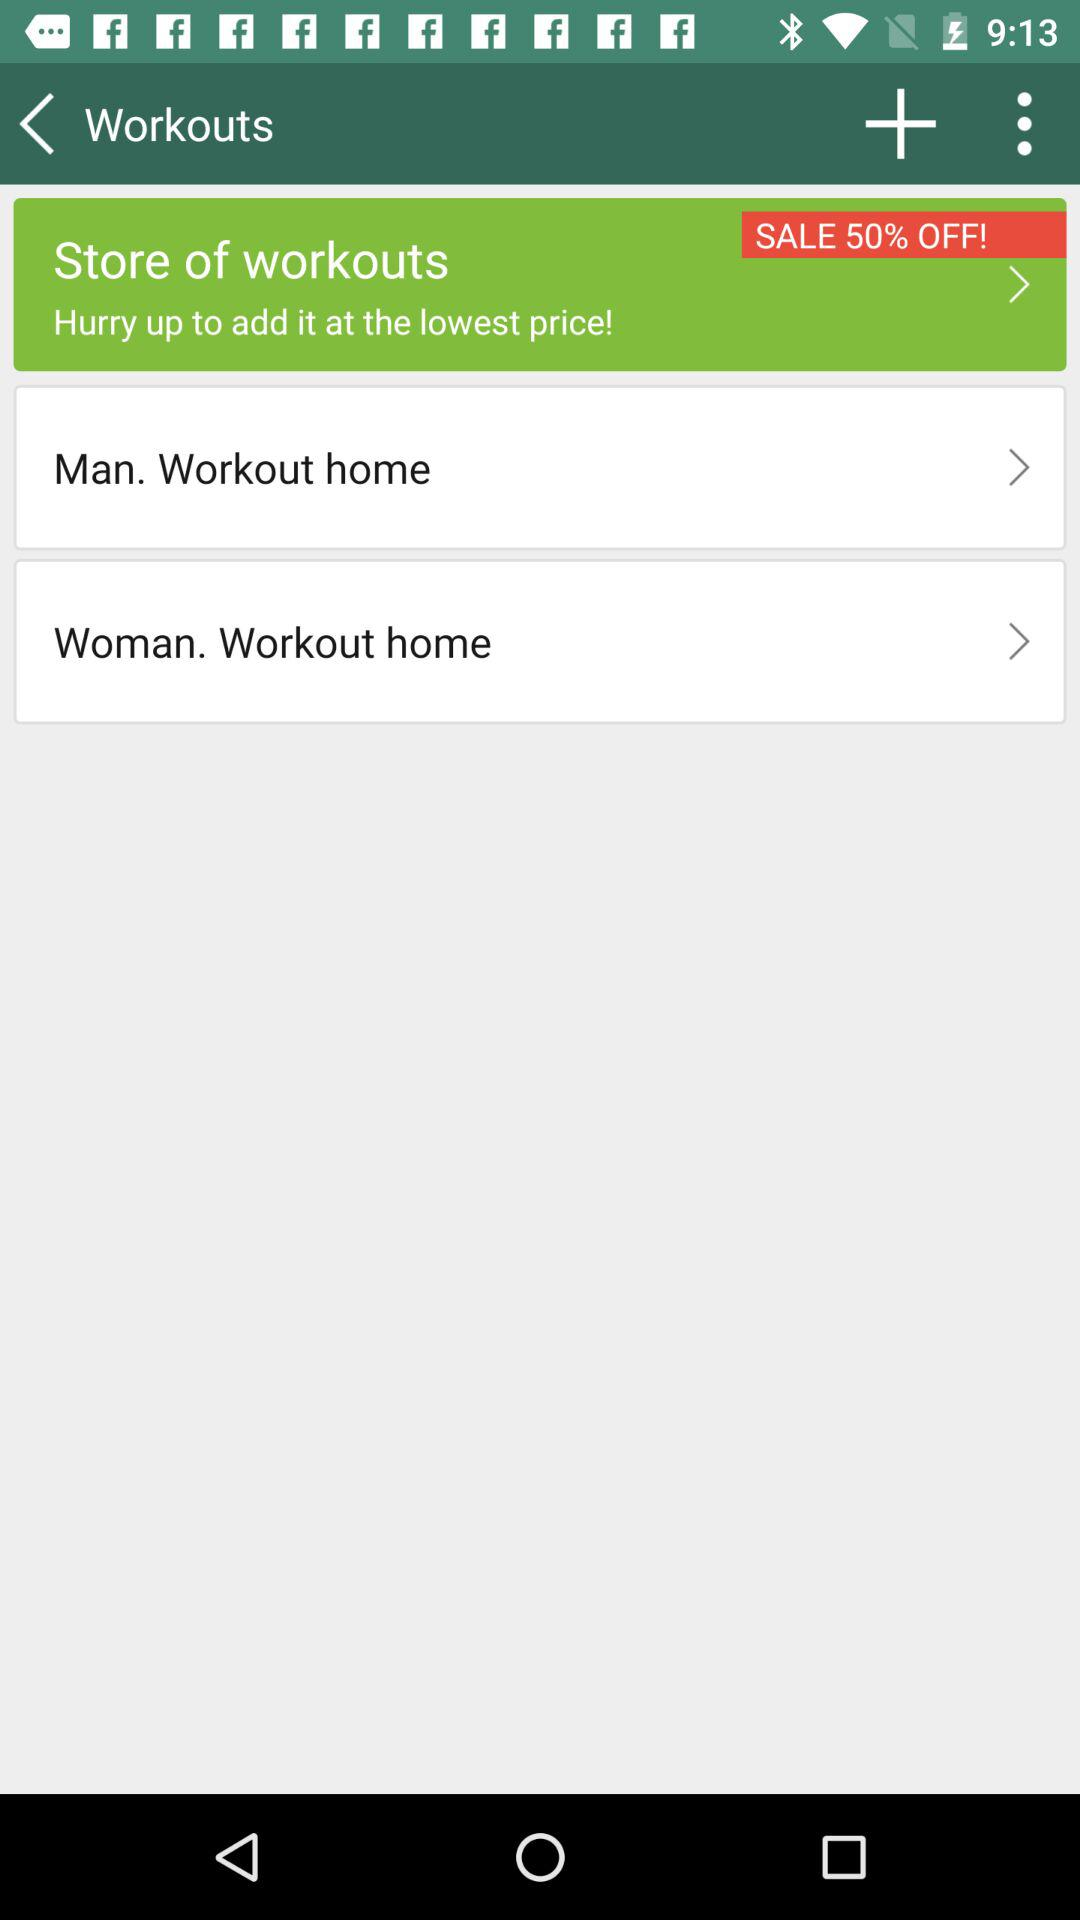What are the options in the "Store of workouts"? The options are "Man. Workout home" and "Woman. Workout home". 